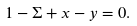<formula> <loc_0><loc_0><loc_500><loc_500>1 - \Sigma + x - y = 0 .</formula> 